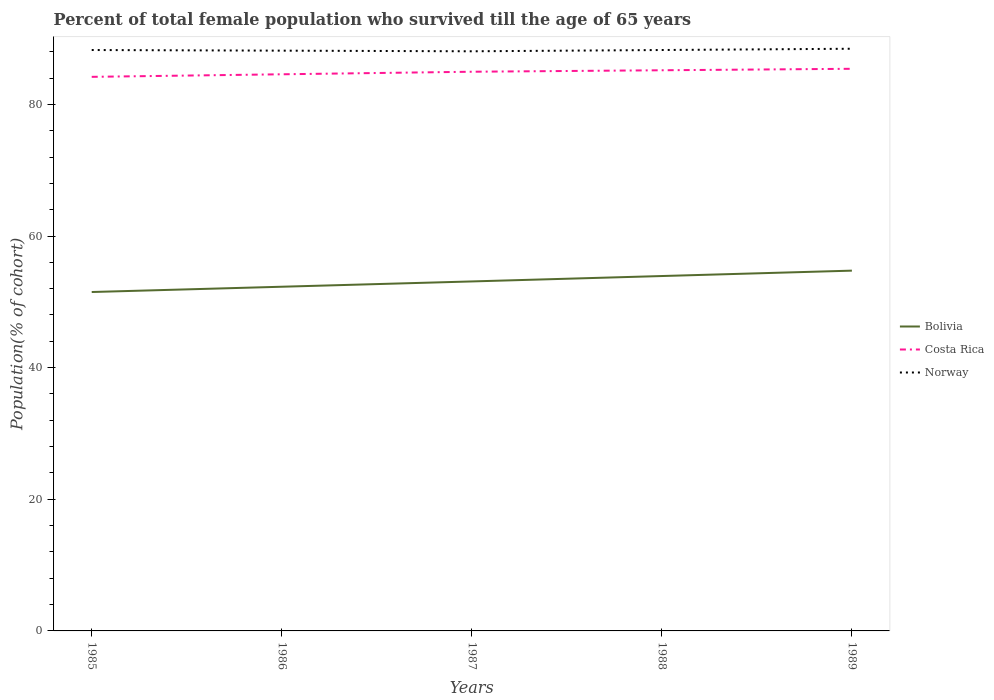How many different coloured lines are there?
Give a very brief answer. 3. Across all years, what is the maximum percentage of total female population who survived till the age of 65 years in Norway?
Your response must be concise. 88.06. What is the total percentage of total female population who survived till the age of 65 years in Norway in the graph?
Keep it short and to the point. -0.1. What is the difference between the highest and the second highest percentage of total female population who survived till the age of 65 years in Bolivia?
Your answer should be very brief. 3.25. How many years are there in the graph?
Provide a succinct answer. 5. What is the difference between two consecutive major ticks on the Y-axis?
Your answer should be compact. 20. Does the graph contain any zero values?
Give a very brief answer. No. Does the graph contain grids?
Make the answer very short. No. How many legend labels are there?
Offer a very short reply. 3. What is the title of the graph?
Give a very brief answer. Percent of total female population who survived till the age of 65 years. What is the label or title of the Y-axis?
Offer a very short reply. Population(% of cohort). What is the Population(% of cohort) of Bolivia in 1985?
Offer a terse response. 51.49. What is the Population(% of cohort) of Costa Rica in 1985?
Ensure brevity in your answer.  84.18. What is the Population(% of cohort) of Norway in 1985?
Ensure brevity in your answer.  88.26. What is the Population(% of cohort) in Bolivia in 1986?
Offer a terse response. 52.29. What is the Population(% of cohort) of Costa Rica in 1986?
Make the answer very short. 84.57. What is the Population(% of cohort) of Norway in 1986?
Make the answer very short. 88.16. What is the Population(% of cohort) of Bolivia in 1987?
Make the answer very short. 53.1. What is the Population(% of cohort) in Costa Rica in 1987?
Your response must be concise. 84.96. What is the Population(% of cohort) of Norway in 1987?
Ensure brevity in your answer.  88.06. What is the Population(% of cohort) in Bolivia in 1988?
Provide a succinct answer. 53.92. What is the Population(% of cohort) in Costa Rica in 1988?
Give a very brief answer. 85.18. What is the Population(% of cohort) in Norway in 1988?
Your answer should be very brief. 88.26. What is the Population(% of cohort) in Bolivia in 1989?
Offer a terse response. 54.74. What is the Population(% of cohort) in Costa Rica in 1989?
Keep it short and to the point. 85.41. What is the Population(% of cohort) in Norway in 1989?
Provide a succinct answer. 88.45. Across all years, what is the maximum Population(% of cohort) in Bolivia?
Provide a short and direct response. 54.74. Across all years, what is the maximum Population(% of cohort) of Costa Rica?
Your response must be concise. 85.41. Across all years, what is the maximum Population(% of cohort) in Norway?
Offer a terse response. 88.45. Across all years, what is the minimum Population(% of cohort) in Bolivia?
Provide a short and direct response. 51.49. Across all years, what is the minimum Population(% of cohort) of Costa Rica?
Ensure brevity in your answer.  84.18. Across all years, what is the minimum Population(% of cohort) of Norway?
Ensure brevity in your answer.  88.06. What is the total Population(% of cohort) in Bolivia in the graph?
Your response must be concise. 265.54. What is the total Population(% of cohort) of Costa Rica in the graph?
Offer a terse response. 424.3. What is the total Population(% of cohort) of Norway in the graph?
Give a very brief answer. 441.19. What is the difference between the Population(% of cohort) of Bolivia in 1985 and that in 1986?
Make the answer very short. -0.8. What is the difference between the Population(% of cohort) of Costa Rica in 1985 and that in 1986?
Keep it short and to the point. -0.39. What is the difference between the Population(% of cohort) of Norway in 1985 and that in 1986?
Offer a terse response. 0.1. What is the difference between the Population(% of cohort) of Bolivia in 1985 and that in 1987?
Your response must be concise. -1.61. What is the difference between the Population(% of cohort) of Costa Rica in 1985 and that in 1987?
Provide a short and direct response. -0.78. What is the difference between the Population(% of cohort) in Norway in 1985 and that in 1987?
Offer a very short reply. 0.19. What is the difference between the Population(% of cohort) of Bolivia in 1985 and that in 1988?
Offer a very short reply. -2.43. What is the difference between the Population(% of cohort) in Costa Rica in 1985 and that in 1988?
Give a very brief answer. -1. What is the difference between the Population(% of cohort) in Norway in 1985 and that in 1988?
Offer a very short reply. -0. What is the difference between the Population(% of cohort) in Bolivia in 1985 and that in 1989?
Ensure brevity in your answer.  -3.25. What is the difference between the Population(% of cohort) of Costa Rica in 1985 and that in 1989?
Your answer should be compact. -1.22. What is the difference between the Population(% of cohort) in Norway in 1985 and that in 1989?
Your response must be concise. -0.19. What is the difference between the Population(% of cohort) of Bolivia in 1986 and that in 1987?
Make the answer very short. -0.8. What is the difference between the Population(% of cohort) of Costa Rica in 1986 and that in 1987?
Offer a terse response. -0.39. What is the difference between the Population(% of cohort) of Norway in 1986 and that in 1987?
Your answer should be compact. 0.1. What is the difference between the Population(% of cohort) in Bolivia in 1986 and that in 1988?
Your answer should be compact. -1.62. What is the difference between the Population(% of cohort) in Costa Rica in 1986 and that in 1988?
Keep it short and to the point. -0.61. What is the difference between the Population(% of cohort) of Norway in 1986 and that in 1988?
Keep it short and to the point. -0.1. What is the difference between the Population(% of cohort) of Bolivia in 1986 and that in 1989?
Offer a very short reply. -2.44. What is the difference between the Population(% of cohort) of Costa Rica in 1986 and that in 1989?
Your answer should be compact. -0.84. What is the difference between the Population(% of cohort) of Norway in 1986 and that in 1989?
Ensure brevity in your answer.  -0.29. What is the difference between the Population(% of cohort) of Bolivia in 1987 and that in 1988?
Your response must be concise. -0.82. What is the difference between the Population(% of cohort) of Costa Rica in 1987 and that in 1988?
Your answer should be very brief. -0.22. What is the difference between the Population(% of cohort) of Norway in 1987 and that in 1988?
Make the answer very short. -0.19. What is the difference between the Population(% of cohort) in Bolivia in 1987 and that in 1989?
Provide a succinct answer. -1.64. What is the difference between the Population(% of cohort) of Costa Rica in 1987 and that in 1989?
Give a very brief answer. -0.45. What is the difference between the Population(% of cohort) of Norway in 1987 and that in 1989?
Your response must be concise. -0.39. What is the difference between the Population(% of cohort) in Bolivia in 1988 and that in 1989?
Your answer should be very brief. -0.82. What is the difference between the Population(% of cohort) in Costa Rica in 1988 and that in 1989?
Your answer should be compact. -0.22. What is the difference between the Population(% of cohort) of Norway in 1988 and that in 1989?
Your answer should be very brief. -0.19. What is the difference between the Population(% of cohort) of Bolivia in 1985 and the Population(% of cohort) of Costa Rica in 1986?
Make the answer very short. -33.08. What is the difference between the Population(% of cohort) of Bolivia in 1985 and the Population(% of cohort) of Norway in 1986?
Offer a very short reply. -36.67. What is the difference between the Population(% of cohort) in Costa Rica in 1985 and the Population(% of cohort) in Norway in 1986?
Your response must be concise. -3.98. What is the difference between the Population(% of cohort) of Bolivia in 1985 and the Population(% of cohort) of Costa Rica in 1987?
Keep it short and to the point. -33.47. What is the difference between the Population(% of cohort) in Bolivia in 1985 and the Population(% of cohort) in Norway in 1987?
Offer a terse response. -36.58. What is the difference between the Population(% of cohort) of Costa Rica in 1985 and the Population(% of cohort) of Norway in 1987?
Provide a succinct answer. -3.88. What is the difference between the Population(% of cohort) of Bolivia in 1985 and the Population(% of cohort) of Costa Rica in 1988?
Ensure brevity in your answer.  -33.69. What is the difference between the Population(% of cohort) in Bolivia in 1985 and the Population(% of cohort) in Norway in 1988?
Make the answer very short. -36.77. What is the difference between the Population(% of cohort) of Costa Rica in 1985 and the Population(% of cohort) of Norway in 1988?
Your response must be concise. -4.08. What is the difference between the Population(% of cohort) of Bolivia in 1985 and the Population(% of cohort) of Costa Rica in 1989?
Give a very brief answer. -33.92. What is the difference between the Population(% of cohort) in Bolivia in 1985 and the Population(% of cohort) in Norway in 1989?
Your answer should be compact. -36.96. What is the difference between the Population(% of cohort) in Costa Rica in 1985 and the Population(% of cohort) in Norway in 1989?
Offer a very short reply. -4.27. What is the difference between the Population(% of cohort) of Bolivia in 1986 and the Population(% of cohort) of Costa Rica in 1987?
Provide a short and direct response. -32.67. What is the difference between the Population(% of cohort) of Bolivia in 1986 and the Population(% of cohort) of Norway in 1987?
Your response must be concise. -35.77. What is the difference between the Population(% of cohort) in Costa Rica in 1986 and the Population(% of cohort) in Norway in 1987?
Offer a terse response. -3.49. What is the difference between the Population(% of cohort) in Bolivia in 1986 and the Population(% of cohort) in Costa Rica in 1988?
Your answer should be compact. -32.89. What is the difference between the Population(% of cohort) of Bolivia in 1986 and the Population(% of cohort) of Norway in 1988?
Offer a terse response. -35.96. What is the difference between the Population(% of cohort) in Costa Rica in 1986 and the Population(% of cohort) in Norway in 1988?
Provide a short and direct response. -3.69. What is the difference between the Population(% of cohort) of Bolivia in 1986 and the Population(% of cohort) of Costa Rica in 1989?
Offer a terse response. -33.11. What is the difference between the Population(% of cohort) in Bolivia in 1986 and the Population(% of cohort) in Norway in 1989?
Provide a short and direct response. -36.16. What is the difference between the Population(% of cohort) in Costa Rica in 1986 and the Population(% of cohort) in Norway in 1989?
Give a very brief answer. -3.88. What is the difference between the Population(% of cohort) of Bolivia in 1987 and the Population(% of cohort) of Costa Rica in 1988?
Give a very brief answer. -32.08. What is the difference between the Population(% of cohort) in Bolivia in 1987 and the Population(% of cohort) in Norway in 1988?
Give a very brief answer. -35.16. What is the difference between the Population(% of cohort) of Costa Rica in 1987 and the Population(% of cohort) of Norway in 1988?
Your answer should be compact. -3.3. What is the difference between the Population(% of cohort) in Bolivia in 1987 and the Population(% of cohort) in Costa Rica in 1989?
Offer a very short reply. -32.31. What is the difference between the Population(% of cohort) in Bolivia in 1987 and the Population(% of cohort) in Norway in 1989?
Your response must be concise. -35.35. What is the difference between the Population(% of cohort) in Costa Rica in 1987 and the Population(% of cohort) in Norway in 1989?
Keep it short and to the point. -3.49. What is the difference between the Population(% of cohort) of Bolivia in 1988 and the Population(% of cohort) of Costa Rica in 1989?
Provide a short and direct response. -31.49. What is the difference between the Population(% of cohort) of Bolivia in 1988 and the Population(% of cohort) of Norway in 1989?
Provide a short and direct response. -34.53. What is the difference between the Population(% of cohort) of Costa Rica in 1988 and the Population(% of cohort) of Norway in 1989?
Provide a short and direct response. -3.27. What is the average Population(% of cohort) of Bolivia per year?
Offer a very short reply. 53.11. What is the average Population(% of cohort) in Costa Rica per year?
Make the answer very short. 84.86. What is the average Population(% of cohort) of Norway per year?
Keep it short and to the point. 88.24. In the year 1985, what is the difference between the Population(% of cohort) in Bolivia and Population(% of cohort) in Costa Rica?
Provide a short and direct response. -32.69. In the year 1985, what is the difference between the Population(% of cohort) of Bolivia and Population(% of cohort) of Norway?
Offer a terse response. -36.77. In the year 1985, what is the difference between the Population(% of cohort) in Costa Rica and Population(% of cohort) in Norway?
Ensure brevity in your answer.  -4.08. In the year 1986, what is the difference between the Population(% of cohort) of Bolivia and Population(% of cohort) of Costa Rica?
Keep it short and to the point. -32.28. In the year 1986, what is the difference between the Population(% of cohort) of Bolivia and Population(% of cohort) of Norway?
Your answer should be compact. -35.87. In the year 1986, what is the difference between the Population(% of cohort) in Costa Rica and Population(% of cohort) in Norway?
Offer a terse response. -3.59. In the year 1987, what is the difference between the Population(% of cohort) of Bolivia and Population(% of cohort) of Costa Rica?
Provide a short and direct response. -31.86. In the year 1987, what is the difference between the Population(% of cohort) in Bolivia and Population(% of cohort) in Norway?
Provide a short and direct response. -34.97. In the year 1987, what is the difference between the Population(% of cohort) of Costa Rica and Population(% of cohort) of Norway?
Offer a very short reply. -3.11. In the year 1988, what is the difference between the Population(% of cohort) in Bolivia and Population(% of cohort) in Costa Rica?
Provide a succinct answer. -31.26. In the year 1988, what is the difference between the Population(% of cohort) of Bolivia and Population(% of cohort) of Norway?
Your answer should be very brief. -34.34. In the year 1988, what is the difference between the Population(% of cohort) in Costa Rica and Population(% of cohort) in Norway?
Your answer should be very brief. -3.08. In the year 1989, what is the difference between the Population(% of cohort) of Bolivia and Population(% of cohort) of Costa Rica?
Your answer should be very brief. -30.67. In the year 1989, what is the difference between the Population(% of cohort) of Bolivia and Population(% of cohort) of Norway?
Ensure brevity in your answer.  -33.71. In the year 1989, what is the difference between the Population(% of cohort) in Costa Rica and Population(% of cohort) in Norway?
Offer a very short reply. -3.05. What is the ratio of the Population(% of cohort) in Bolivia in 1985 to that in 1986?
Provide a short and direct response. 0.98. What is the ratio of the Population(% of cohort) of Costa Rica in 1985 to that in 1986?
Your answer should be compact. 1. What is the ratio of the Population(% of cohort) in Bolivia in 1985 to that in 1987?
Provide a short and direct response. 0.97. What is the ratio of the Population(% of cohort) of Costa Rica in 1985 to that in 1987?
Keep it short and to the point. 0.99. What is the ratio of the Population(% of cohort) of Norway in 1985 to that in 1987?
Your response must be concise. 1. What is the ratio of the Population(% of cohort) in Bolivia in 1985 to that in 1988?
Ensure brevity in your answer.  0.95. What is the ratio of the Population(% of cohort) in Costa Rica in 1985 to that in 1988?
Give a very brief answer. 0.99. What is the ratio of the Population(% of cohort) of Bolivia in 1985 to that in 1989?
Ensure brevity in your answer.  0.94. What is the ratio of the Population(% of cohort) in Costa Rica in 1985 to that in 1989?
Offer a terse response. 0.99. What is the ratio of the Population(% of cohort) in Norway in 1985 to that in 1989?
Keep it short and to the point. 1. What is the ratio of the Population(% of cohort) of Bolivia in 1986 to that in 1987?
Make the answer very short. 0.98. What is the ratio of the Population(% of cohort) of Costa Rica in 1986 to that in 1987?
Offer a very short reply. 1. What is the ratio of the Population(% of cohort) of Bolivia in 1986 to that in 1988?
Offer a terse response. 0.97. What is the ratio of the Population(% of cohort) in Costa Rica in 1986 to that in 1988?
Provide a succinct answer. 0.99. What is the ratio of the Population(% of cohort) in Bolivia in 1986 to that in 1989?
Offer a terse response. 0.96. What is the ratio of the Population(% of cohort) of Costa Rica in 1986 to that in 1989?
Make the answer very short. 0.99. What is the ratio of the Population(% of cohort) in Bolivia in 1987 to that in 1988?
Keep it short and to the point. 0.98. What is the ratio of the Population(% of cohort) in Costa Rica in 1987 to that in 1988?
Give a very brief answer. 1. What is the ratio of the Population(% of cohort) of Norway in 1987 to that in 1988?
Provide a short and direct response. 1. What is the ratio of the Population(% of cohort) in Norway in 1987 to that in 1989?
Your answer should be very brief. 1. What is the ratio of the Population(% of cohort) of Norway in 1988 to that in 1989?
Give a very brief answer. 1. What is the difference between the highest and the second highest Population(% of cohort) in Bolivia?
Offer a terse response. 0.82. What is the difference between the highest and the second highest Population(% of cohort) in Costa Rica?
Keep it short and to the point. 0.22. What is the difference between the highest and the second highest Population(% of cohort) in Norway?
Provide a succinct answer. 0.19. What is the difference between the highest and the lowest Population(% of cohort) in Bolivia?
Provide a short and direct response. 3.25. What is the difference between the highest and the lowest Population(% of cohort) of Costa Rica?
Your answer should be compact. 1.22. What is the difference between the highest and the lowest Population(% of cohort) of Norway?
Offer a terse response. 0.39. 